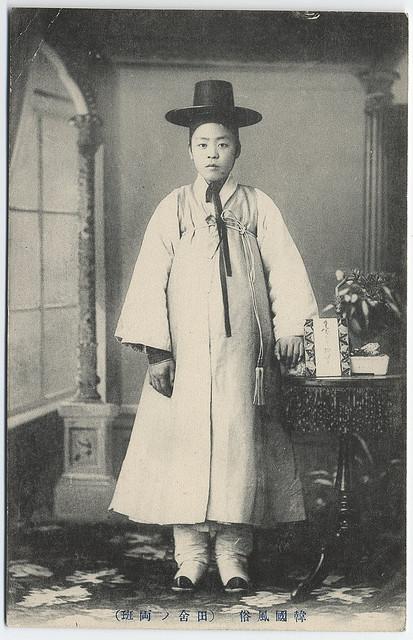Was this picture taken prior to 2015?
Short answer required. Yes. How many people are here?
Answer briefly. 1. What country is this person from?
Write a very short answer. China. 